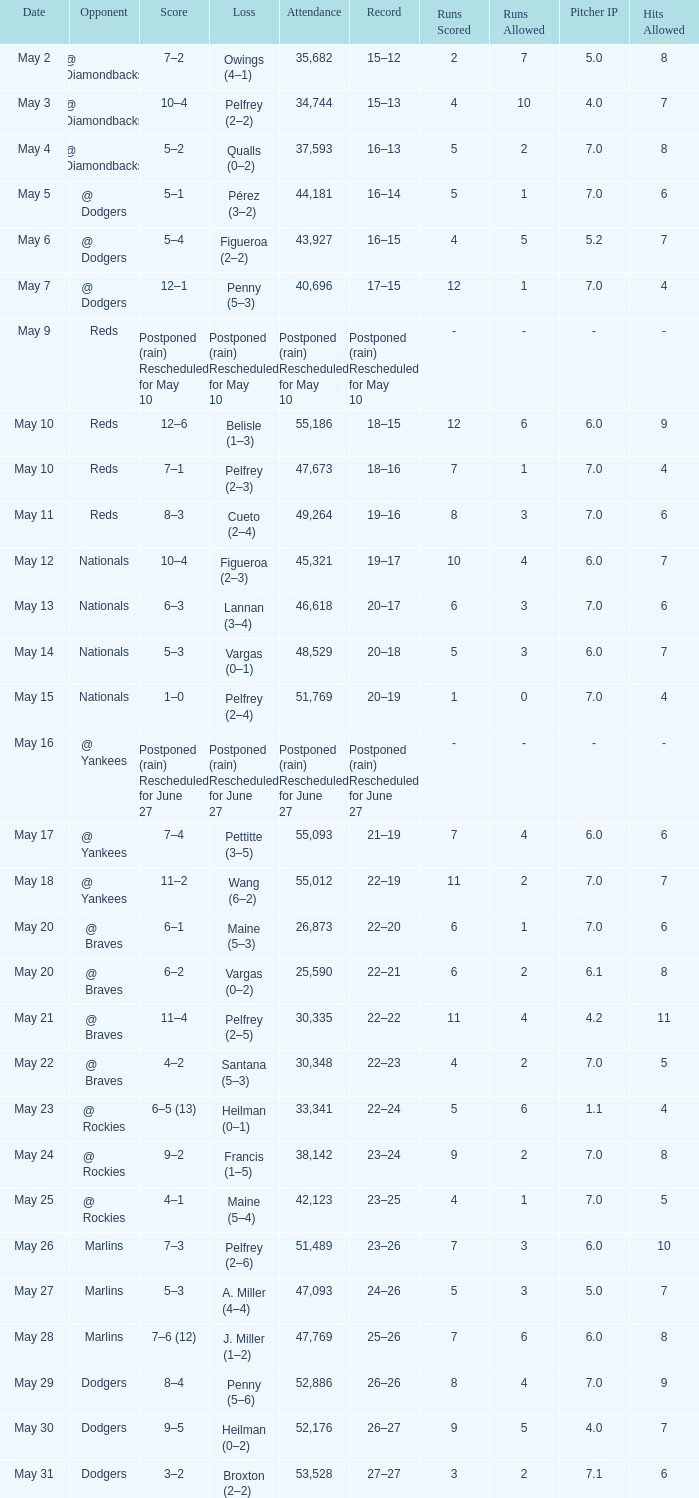Help me parse the entirety of this table. {'header': ['Date', 'Opponent', 'Score', 'Loss', 'Attendance', 'Record', 'Runs Scored', 'Runs Allowed', 'Pitcher IP', 'Hits Allowed'], 'rows': [['May 2', '@ Diamondbacks', '7–2', 'Owings (4–1)', '35,682', '15–12', '2', '7', '5.0', '8'], ['May 3', '@ Diamondbacks', '10–4', 'Pelfrey (2–2)', '34,744', '15–13', '4', '10', '4.0', '7'], ['May 4', '@ Diamondbacks', '5–2', 'Qualls (0–2)', '37,593', '16–13', '5', '2', '7.0', '8'], ['May 5', '@ Dodgers', '5–1', 'Pérez (3–2)', '44,181', '16–14', '5', '1', '7.0', '6'], ['May 6', '@ Dodgers', '5–4', 'Figueroa (2–2)', '43,927', '16–15', '4', '5', '5.2', '7'], ['May 7', '@ Dodgers', '12–1', 'Penny (5–3)', '40,696', '17–15', '12', '1', '7.0', '4'], ['May 9', 'Reds', 'Postponed (rain) Rescheduled for May 10', 'Postponed (rain) Rescheduled for May 10', 'Postponed (rain) Rescheduled for May 10', 'Postponed (rain) Rescheduled for May 10', '-', '-', '-', '-'], ['May 10', 'Reds', '12–6', 'Belisle (1–3)', '55,186', '18–15', '12', '6', '6.0', '9'], ['May 10', 'Reds', '7–1', 'Pelfrey (2–3)', '47,673', '18–16', '7', '1', '7.0', '4'], ['May 11', 'Reds', '8–3', 'Cueto (2–4)', '49,264', '19–16', '8', '3', '7.0', '6'], ['May 12', 'Nationals', '10–4', 'Figueroa (2–3)', '45,321', '19–17', '10', '4', '6.0', '7'], ['May 13', 'Nationals', '6–3', 'Lannan (3–4)', '46,618', '20–17', '6', '3', '7.0', '6'], ['May 14', 'Nationals', '5–3', 'Vargas (0–1)', '48,529', '20–18', '5', '3', '6.0', '7'], ['May 15', 'Nationals', '1–0', 'Pelfrey (2–4)', '51,769', '20–19', '1', '0', '7.0', '4'], ['May 16', '@ Yankees', 'Postponed (rain) Rescheduled for June 27', 'Postponed (rain) Rescheduled for June 27', 'Postponed (rain) Rescheduled for June 27', 'Postponed (rain) Rescheduled for June 27', '-', '-', '-', '-'], ['May 17', '@ Yankees', '7–4', 'Pettitte (3–5)', '55,093', '21–19', '7', '4', '6.0', '6'], ['May 18', '@ Yankees', '11–2', 'Wang (6–2)', '55,012', '22–19', '11', '2', '7.0', '7'], ['May 20', '@ Braves', '6–1', 'Maine (5–3)', '26,873', '22–20', '6', '1', '7.0', '6'], ['May 20', '@ Braves', '6–2', 'Vargas (0–2)', '25,590', '22–21', '6', '2', '6.1', '8'], ['May 21', '@ Braves', '11–4', 'Pelfrey (2–5)', '30,335', '22–22', '11', '4', '4.2', '11'], ['May 22', '@ Braves', '4–2', 'Santana (5–3)', '30,348', '22–23', '4', '2', '7.0', '5'], ['May 23', '@ Rockies', '6–5 (13)', 'Heilman (0–1)', '33,341', '22–24', '5', '6', '1.1', '4'], ['May 24', '@ Rockies', '9–2', 'Francis (1–5)', '38,142', '23–24', '9', '2', '7.0', '8'], ['May 25', '@ Rockies', '4–1', 'Maine (5–4)', '42,123', '23–25', '4', '1', '7.0', '5'], ['May 26', 'Marlins', '7–3', 'Pelfrey (2–6)', '51,489', '23–26', '7', '3', '6.0', '10'], ['May 27', 'Marlins', '5–3', 'A. Miller (4–4)', '47,093', '24–26', '5', '3', '5.0', '7'], ['May 28', 'Marlins', '7–6 (12)', 'J. Miller (1–2)', '47,769', '25–26', '7', '6', '6.0', '8'], ['May 29', 'Dodgers', '8–4', 'Penny (5–6)', '52,886', '26–26', '8', '4', '7.0', '9'], ['May 30', 'Dodgers', '9–5', 'Heilman (0–2)', '52,176', '26–27', '9', '5', '4.0', '7'], ['May 31', 'Dodgers', '3–2', 'Broxton (2–2)', '53,528', '27–27', '3', '2', '7.1', '6']]} Opponent of @ braves, and a Loss of pelfrey (2–5) had what score? 11–4. 